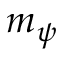<formula> <loc_0><loc_0><loc_500><loc_500>m _ { \psi }</formula> 